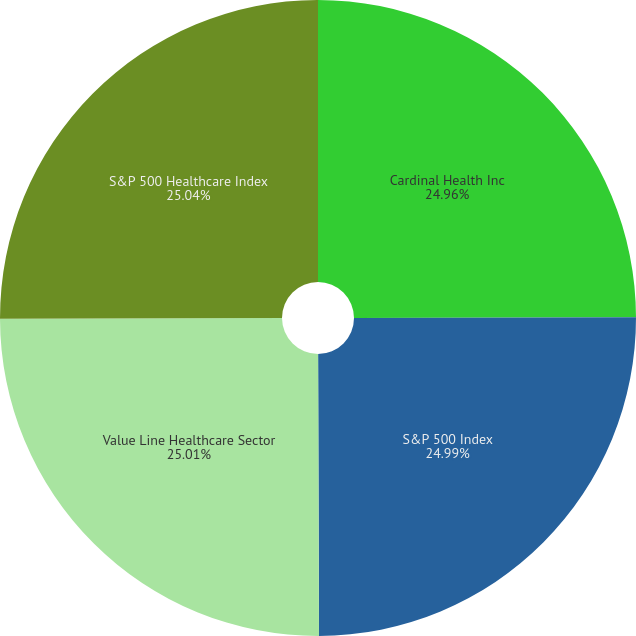Convert chart to OTSL. <chart><loc_0><loc_0><loc_500><loc_500><pie_chart><fcel>Cardinal Health Inc<fcel>S&P 500 Index<fcel>Value Line Healthcare Sector<fcel>S&P 500 Healthcare Index<nl><fcel>24.96%<fcel>24.99%<fcel>25.01%<fcel>25.04%<nl></chart> 